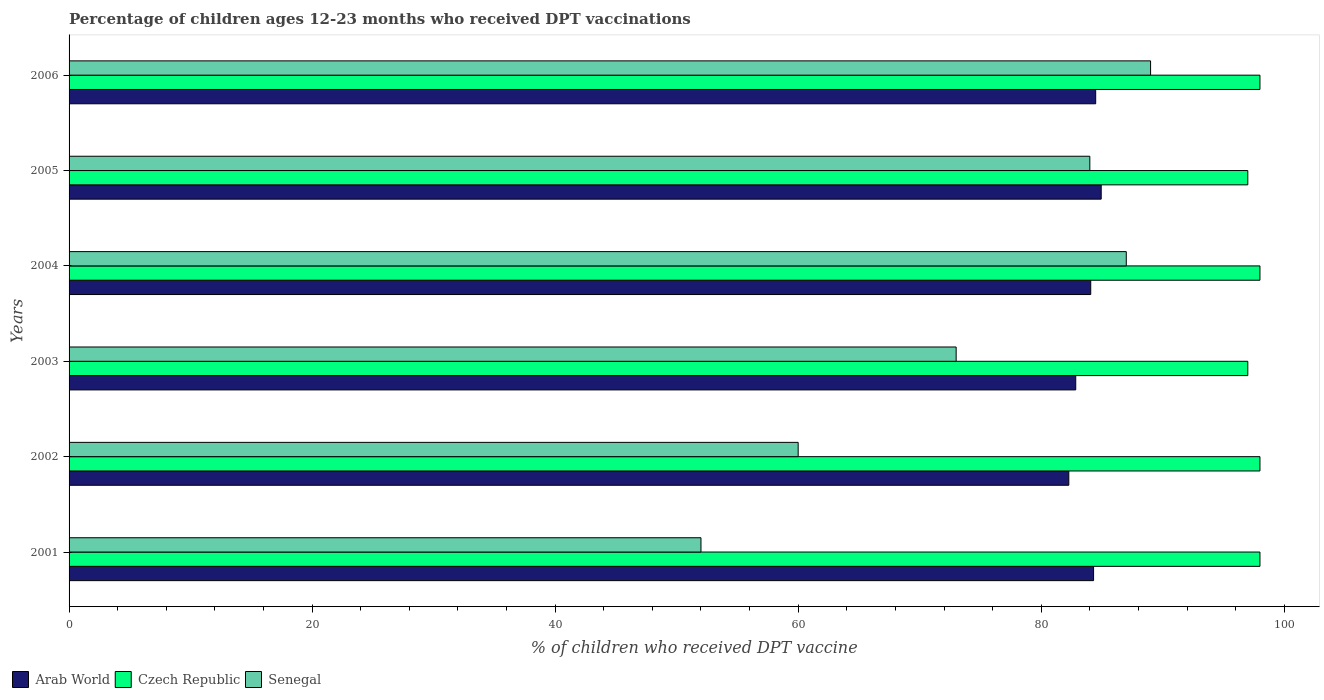Are the number of bars per tick equal to the number of legend labels?
Provide a succinct answer. Yes. Are the number of bars on each tick of the Y-axis equal?
Provide a succinct answer. Yes. How many bars are there on the 6th tick from the bottom?
Your response must be concise. 3. What is the label of the 5th group of bars from the top?
Your answer should be compact. 2002. Across all years, what is the maximum percentage of children who received DPT vaccination in Arab World?
Your answer should be compact. 84.94. Across all years, what is the minimum percentage of children who received DPT vaccination in Arab World?
Your response must be concise. 82.27. What is the total percentage of children who received DPT vaccination in Arab World in the graph?
Offer a very short reply. 502.92. What is the difference between the percentage of children who received DPT vaccination in Arab World in 2001 and that in 2003?
Your answer should be compact. 1.47. What is the difference between the percentage of children who received DPT vaccination in Czech Republic in 2006 and the percentage of children who received DPT vaccination in Senegal in 2003?
Offer a terse response. 25. What is the average percentage of children who received DPT vaccination in Senegal per year?
Offer a terse response. 74.17. In the year 2002, what is the difference between the percentage of children who received DPT vaccination in Czech Republic and percentage of children who received DPT vaccination in Arab World?
Your response must be concise. 15.73. What is the ratio of the percentage of children who received DPT vaccination in Senegal in 2001 to that in 2002?
Your response must be concise. 0.87. Is the percentage of children who received DPT vaccination in Senegal in 2005 less than that in 2006?
Offer a very short reply. Yes. What is the difference between the highest and the lowest percentage of children who received DPT vaccination in Arab World?
Your response must be concise. 2.67. Is the sum of the percentage of children who received DPT vaccination in Senegal in 2001 and 2005 greater than the maximum percentage of children who received DPT vaccination in Czech Republic across all years?
Give a very brief answer. Yes. What does the 2nd bar from the top in 2006 represents?
Make the answer very short. Czech Republic. What does the 1st bar from the bottom in 2005 represents?
Offer a terse response. Arab World. How many bars are there?
Offer a terse response. 18. What is the difference between two consecutive major ticks on the X-axis?
Give a very brief answer. 20. Does the graph contain grids?
Your answer should be compact. No. How many legend labels are there?
Offer a terse response. 3. What is the title of the graph?
Provide a succinct answer. Percentage of children ages 12-23 months who received DPT vaccinations. What is the label or title of the X-axis?
Make the answer very short. % of children who received DPT vaccine. What is the label or title of the Y-axis?
Your answer should be very brief. Years. What is the % of children who received DPT vaccine in Arab World in 2001?
Ensure brevity in your answer.  84.31. What is the % of children who received DPT vaccine of Arab World in 2002?
Your answer should be compact. 82.27. What is the % of children who received DPT vaccine of Arab World in 2003?
Provide a short and direct response. 82.84. What is the % of children who received DPT vaccine of Czech Republic in 2003?
Offer a very short reply. 97. What is the % of children who received DPT vaccine of Arab World in 2004?
Offer a terse response. 84.08. What is the % of children who received DPT vaccine of Arab World in 2005?
Ensure brevity in your answer.  84.94. What is the % of children who received DPT vaccine of Czech Republic in 2005?
Offer a very short reply. 97. What is the % of children who received DPT vaccine in Arab World in 2006?
Ensure brevity in your answer.  84.48. What is the % of children who received DPT vaccine in Senegal in 2006?
Provide a short and direct response. 89. Across all years, what is the maximum % of children who received DPT vaccine of Arab World?
Offer a terse response. 84.94. Across all years, what is the maximum % of children who received DPT vaccine in Czech Republic?
Offer a terse response. 98. Across all years, what is the maximum % of children who received DPT vaccine in Senegal?
Your response must be concise. 89. Across all years, what is the minimum % of children who received DPT vaccine in Arab World?
Give a very brief answer. 82.27. Across all years, what is the minimum % of children who received DPT vaccine of Czech Republic?
Provide a succinct answer. 97. What is the total % of children who received DPT vaccine in Arab World in the graph?
Your answer should be very brief. 502.92. What is the total % of children who received DPT vaccine in Czech Republic in the graph?
Your response must be concise. 586. What is the total % of children who received DPT vaccine of Senegal in the graph?
Provide a short and direct response. 445. What is the difference between the % of children who received DPT vaccine of Arab World in 2001 and that in 2002?
Provide a short and direct response. 2.04. What is the difference between the % of children who received DPT vaccine of Senegal in 2001 and that in 2002?
Make the answer very short. -8. What is the difference between the % of children who received DPT vaccine of Arab World in 2001 and that in 2003?
Provide a succinct answer. 1.47. What is the difference between the % of children who received DPT vaccine in Czech Republic in 2001 and that in 2003?
Make the answer very short. 1. What is the difference between the % of children who received DPT vaccine in Arab World in 2001 and that in 2004?
Give a very brief answer. 0.23. What is the difference between the % of children who received DPT vaccine of Czech Republic in 2001 and that in 2004?
Your answer should be very brief. 0. What is the difference between the % of children who received DPT vaccine in Senegal in 2001 and that in 2004?
Give a very brief answer. -35. What is the difference between the % of children who received DPT vaccine in Arab World in 2001 and that in 2005?
Keep it short and to the point. -0.63. What is the difference between the % of children who received DPT vaccine of Senegal in 2001 and that in 2005?
Make the answer very short. -32. What is the difference between the % of children who received DPT vaccine in Arab World in 2001 and that in 2006?
Offer a very short reply. -0.17. What is the difference between the % of children who received DPT vaccine of Senegal in 2001 and that in 2006?
Keep it short and to the point. -37. What is the difference between the % of children who received DPT vaccine in Arab World in 2002 and that in 2003?
Provide a short and direct response. -0.57. What is the difference between the % of children who received DPT vaccine of Czech Republic in 2002 and that in 2003?
Make the answer very short. 1. What is the difference between the % of children who received DPT vaccine of Arab World in 2002 and that in 2004?
Offer a terse response. -1.8. What is the difference between the % of children who received DPT vaccine of Senegal in 2002 and that in 2004?
Offer a very short reply. -27. What is the difference between the % of children who received DPT vaccine in Arab World in 2002 and that in 2005?
Provide a succinct answer. -2.67. What is the difference between the % of children who received DPT vaccine in Czech Republic in 2002 and that in 2005?
Your answer should be very brief. 1. What is the difference between the % of children who received DPT vaccine of Senegal in 2002 and that in 2005?
Offer a very short reply. -24. What is the difference between the % of children who received DPT vaccine in Arab World in 2002 and that in 2006?
Provide a succinct answer. -2.21. What is the difference between the % of children who received DPT vaccine of Czech Republic in 2002 and that in 2006?
Your answer should be very brief. 0. What is the difference between the % of children who received DPT vaccine of Arab World in 2003 and that in 2004?
Offer a terse response. -1.23. What is the difference between the % of children who received DPT vaccine in Czech Republic in 2003 and that in 2004?
Offer a terse response. -1. What is the difference between the % of children who received DPT vaccine of Arab World in 2003 and that in 2005?
Offer a very short reply. -2.1. What is the difference between the % of children who received DPT vaccine in Czech Republic in 2003 and that in 2005?
Make the answer very short. 0. What is the difference between the % of children who received DPT vaccine in Arab World in 2003 and that in 2006?
Provide a short and direct response. -1.64. What is the difference between the % of children who received DPT vaccine of Czech Republic in 2003 and that in 2006?
Make the answer very short. -1. What is the difference between the % of children who received DPT vaccine of Arab World in 2004 and that in 2005?
Your answer should be very brief. -0.86. What is the difference between the % of children who received DPT vaccine in Czech Republic in 2004 and that in 2005?
Provide a succinct answer. 1. What is the difference between the % of children who received DPT vaccine in Arab World in 2004 and that in 2006?
Give a very brief answer. -0.41. What is the difference between the % of children who received DPT vaccine of Czech Republic in 2004 and that in 2006?
Provide a short and direct response. 0. What is the difference between the % of children who received DPT vaccine in Senegal in 2004 and that in 2006?
Make the answer very short. -2. What is the difference between the % of children who received DPT vaccine in Arab World in 2005 and that in 2006?
Ensure brevity in your answer.  0.45. What is the difference between the % of children who received DPT vaccine in Arab World in 2001 and the % of children who received DPT vaccine in Czech Republic in 2002?
Make the answer very short. -13.69. What is the difference between the % of children who received DPT vaccine of Arab World in 2001 and the % of children who received DPT vaccine of Senegal in 2002?
Offer a very short reply. 24.31. What is the difference between the % of children who received DPT vaccine in Czech Republic in 2001 and the % of children who received DPT vaccine in Senegal in 2002?
Your answer should be compact. 38. What is the difference between the % of children who received DPT vaccine in Arab World in 2001 and the % of children who received DPT vaccine in Czech Republic in 2003?
Keep it short and to the point. -12.69. What is the difference between the % of children who received DPT vaccine of Arab World in 2001 and the % of children who received DPT vaccine of Senegal in 2003?
Provide a succinct answer. 11.31. What is the difference between the % of children who received DPT vaccine of Arab World in 2001 and the % of children who received DPT vaccine of Czech Republic in 2004?
Your answer should be compact. -13.69. What is the difference between the % of children who received DPT vaccine in Arab World in 2001 and the % of children who received DPT vaccine in Senegal in 2004?
Keep it short and to the point. -2.69. What is the difference between the % of children who received DPT vaccine of Czech Republic in 2001 and the % of children who received DPT vaccine of Senegal in 2004?
Your response must be concise. 11. What is the difference between the % of children who received DPT vaccine in Arab World in 2001 and the % of children who received DPT vaccine in Czech Republic in 2005?
Your answer should be very brief. -12.69. What is the difference between the % of children who received DPT vaccine in Arab World in 2001 and the % of children who received DPT vaccine in Senegal in 2005?
Provide a short and direct response. 0.31. What is the difference between the % of children who received DPT vaccine in Czech Republic in 2001 and the % of children who received DPT vaccine in Senegal in 2005?
Ensure brevity in your answer.  14. What is the difference between the % of children who received DPT vaccine of Arab World in 2001 and the % of children who received DPT vaccine of Czech Republic in 2006?
Make the answer very short. -13.69. What is the difference between the % of children who received DPT vaccine of Arab World in 2001 and the % of children who received DPT vaccine of Senegal in 2006?
Your response must be concise. -4.69. What is the difference between the % of children who received DPT vaccine in Arab World in 2002 and the % of children who received DPT vaccine in Czech Republic in 2003?
Make the answer very short. -14.73. What is the difference between the % of children who received DPT vaccine in Arab World in 2002 and the % of children who received DPT vaccine in Senegal in 2003?
Give a very brief answer. 9.27. What is the difference between the % of children who received DPT vaccine of Czech Republic in 2002 and the % of children who received DPT vaccine of Senegal in 2003?
Provide a short and direct response. 25. What is the difference between the % of children who received DPT vaccine of Arab World in 2002 and the % of children who received DPT vaccine of Czech Republic in 2004?
Offer a terse response. -15.73. What is the difference between the % of children who received DPT vaccine of Arab World in 2002 and the % of children who received DPT vaccine of Senegal in 2004?
Your response must be concise. -4.73. What is the difference between the % of children who received DPT vaccine of Czech Republic in 2002 and the % of children who received DPT vaccine of Senegal in 2004?
Your answer should be compact. 11. What is the difference between the % of children who received DPT vaccine in Arab World in 2002 and the % of children who received DPT vaccine in Czech Republic in 2005?
Offer a terse response. -14.73. What is the difference between the % of children who received DPT vaccine of Arab World in 2002 and the % of children who received DPT vaccine of Senegal in 2005?
Offer a terse response. -1.73. What is the difference between the % of children who received DPT vaccine in Czech Republic in 2002 and the % of children who received DPT vaccine in Senegal in 2005?
Your response must be concise. 14. What is the difference between the % of children who received DPT vaccine of Arab World in 2002 and the % of children who received DPT vaccine of Czech Republic in 2006?
Provide a short and direct response. -15.73. What is the difference between the % of children who received DPT vaccine of Arab World in 2002 and the % of children who received DPT vaccine of Senegal in 2006?
Offer a very short reply. -6.73. What is the difference between the % of children who received DPT vaccine of Czech Republic in 2002 and the % of children who received DPT vaccine of Senegal in 2006?
Your answer should be very brief. 9. What is the difference between the % of children who received DPT vaccine in Arab World in 2003 and the % of children who received DPT vaccine in Czech Republic in 2004?
Offer a terse response. -15.16. What is the difference between the % of children who received DPT vaccine in Arab World in 2003 and the % of children who received DPT vaccine in Senegal in 2004?
Your response must be concise. -4.16. What is the difference between the % of children who received DPT vaccine in Arab World in 2003 and the % of children who received DPT vaccine in Czech Republic in 2005?
Your answer should be compact. -14.16. What is the difference between the % of children who received DPT vaccine of Arab World in 2003 and the % of children who received DPT vaccine of Senegal in 2005?
Ensure brevity in your answer.  -1.16. What is the difference between the % of children who received DPT vaccine in Arab World in 2003 and the % of children who received DPT vaccine in Czech Republic in 2006?
Offer a very short reply. -15.16. What is the difference between the % of children who received DPT vaccine of Arab World in 2003 and the % of children who received DPT vaccine of Senegal in 2006?
Make the answer very short. -6.16. What is the difference between the % of children who received DPT vaccine of Czech Republic in 2003 and the % of children who received DPT vaccine of Senegal in 2006?
Keep it short and to the point. 8. What is the difference between the % of children who received DPT vaccine of Arab World in 2004 and the % of children who received DPT vaccine of Czech Republic in 2005?
Your answer should be compact. -12.92. What is the difference between the % of children who received DPT vaccine in Arab World in 2004 and the % of children who received DPT vaccine in Senegal in 2005?
Your answer should be compact. 0.08. What is the difference between the % of children who received DPT vaccine of Arab World in 2004 and the % of children who received DPT vaccine of Czech Republic in 2006?
Offer a very short reply. -13.92. What is the difference between the % of children who received DPT vaccine in Arab World in 2004 and the % of children who received DPT vaccine in Senegal in 2006?
Keep it short and to the point. -4.92. What is the difference between the % of children who received DPT vaccine in Arab World in 2005 and the % of children who received DPT vaccine in Czech Republic in 2006?
Your answer should be compact. -13.06. What is the difference between the % of children who received DPT vaccine in Arab World in 2005 and the % of children who received DPT vaccine in Senegal in 2006?
Provide a succinct answer. -4.06. What is the difference between the % of children who received DPT vaccine of Czech Republic in 2005 and the % of children who received DPT vaccine of Senegal in 2006?
Keep it short and to the point. 8. What is the average % of children who received DPT vaccine in Arab World per year?
Make the answer very short. 83.82. What is the average % of children who received DPT vaccine in Czech Republic per year?
Your answer should be compact. 97.67. What is the average % of children who received DPT vaccine of Senegal per year?
Ensure brevity in your answer.  74.17. In the year 2001, what is the difference between the % of children who received DPT vaccine in Arab World and % of children who received DPT vaccine in Czech Republic?
Your answer should be compact. -13.69. In the year 2001, what is the difference between the % of children who received DPT vaccine of Arab World and % of children who received DPT vaccine of Senegal?
Give a very brief answer. 32.31. In the year 2001, what is the difference between the % of children who received DPT vaccine in Czech Republic and % of children who received DPT vaccine in Senegal?
Keep it short and to the point. 46. In the year 2002, what is the difference between the % of children who received DPT vaccine of Arab World and % of children who received DPT vaccine of Czech Republic?
Offer a terse response. -15.73. In the year 2002, what is the difference between the % of children who received DPT vaccine in Arab World and % of children who received DPT vaccine in Senegal?
Offer a very short reply. 22.27. In the year 2002, what is the difference between the % of children who received DPT vaccine in Czech Republic and % of children who received DPT vaccine in Senegal?
Make the answer very short. 38. In the year 2003, what is the difference between the % of children who received DPT vaccine in Arab World and % of children who received DPT vaccine in Czech Republic?
Provide a succinct answer. -14.16. In the year 2003, what is the difference between the % of children who received DPT vaccine of Arab World and % of children who received DPT vaccine of Senegal?
Your answer should be compact. 9.84. In the year 2003, what is the difference between the % of children who received DPT vaccine of Czech Republic and % of children who received DPT vaccine of Senegal?
Provide a succinct answer. 24. In the year 2004, what is the difference between the % of children who received DPT vaccine of Arab World and % of children who received DPT vaccine of Czech Republic?
Make the answer very short. -13.92. In the year 2004, what is the difference between the % of children who received DPT vaccine of Arab World and % of children who received DPT vaccine of Senegal?
Ensure brevity in your answer.  -2.92. In the year 2004, what is the difference between the % of children who received DPT vaccine in Czech Republic and % of children who received DPT vaccine in Senegal?
Offer a very short reply. 11. In the year 2005, what is the difference between the % of children who received DPT vaccine of Arab World and % of children who received DPT vaccine of Czech Republic?
Keep it short and to the point. -12.06. In the year 2005, what is the difference between the % of children who received DPT vaccine in Arab World and % of children who received DPT vaccine in Senegal?
Your answer should be very brief. 0.94. In the year 2006, what is the difference between the % of children who received DPT vaccine in Arab World and % of children who received DPT vaccine in Czech Republic?
Offer a very short reply. -13.52. In the year 2006, what is the difference between the % of children who received DPT vaccine of Arab World and % of children who received DPT vaccine of Senegal?
Offer a terse response. -4.52. In the year 2006, what is the difference between the % of children who received DPT vaccine of Czech Republic and % of children who received DPT vaccine of Senegal?
Provide a short and direct response. 9. What is the ratio of the % of children who received DPT vaccine in Arab World in 2001 to that in 2002?
Your answer should be very brief. 1.02. What is the ratio of the % of children who received DPT vaccine of Czech Republic in 2001 to that in 2002?
Offer a very short reply. 1. What is the ratio of the % of children who received DPT vaccine in Senegal in 2001 to that in 2002?
Make the answer very short. 0.87. What is the ratio of the % of children who received DPT vaccine of Arab World in 2001 to that in 2003?
Your answer should be compact. 1.02. What is the ratio of the % of children who received DPT vaccine of Czech Republic in 2001 to that in 2003?
Give a very brief answer. 1.01. What is the ratio of the % of children who received DPT vaccine in Senegal in 2001 to that in 2003?
Keep it short and to the point. 0.71. What is the ratio of the % of children who received DPT vaccine of Senegal in 2001 to that in 2004?
Give a very brief answer. 0.6. What is the ratio of the % of children who received DPT vaccine in Czech Republic in 2001 to that in 2005?
Make the answer very short. 1.01. What is the ratio of the % of children who received DPT vaccine of Senegal in 2001 to that in 2005?
Provide a succinct answer. 0.62. What is the ratio of the % of children who received DPT vaccine of Arab World in 2001 to that in 2006?
Keep it short and to the point. 1. What is the ratio of the % of children who received DPT vaccine of Czech Republic in 2001 to that in 2006?
Make the answer very short. 1. What is the ratio of the % of children who received DPT vaccine in Senegal in 2001 to that in 2006?
Provide a succinct answer. 0.58. What is the ratio of the % of children who received DPT vaccine in Arab World in 2002 to that in 2003?
Provide a succinct answer. 0.99. What is the ratio of the % of children who received DPT vaccine in Czech Republic in 2002 to that in 2003?
Ensure brevity in your answer.  1.01. What is the ratio of the % of children who received DPT vaccine in Senegal in 2002 to that in 2003?
Keep it short and to the point. 0.82. What is the ratio of the % of children who received DPT vaccine in Arab World in 2002 to that in 2004?
Your answer should be very brief. 0.98. What is the ratio of the % of children who received DPT vaccine in Czech Republic in 2002 to that in 2004?
Make the answer very short. 1. What is the ratio of the % of children who received DPT vaccine in Senegal in 2002 to that in 2004?
Keep it short and to the point. 0.69. What is the ratio of the % of children who received DPT vaccine in Arab World in 2002 to that in 2005?
Your response must be concise. 0.97. What is the ratio of the % of children who received DPT vaccine of Czech Republic in 2002 to that in 2005?
Ensure brevity in your answer.  1.01. What is the ratio of the % of children who received DPT vaccine in Senegal in 2002 to that in 2005?
Your response must be concise. 0.71. What is the ratio of the % of children who received DPT vaccine in Arab World in 2002 to that in 2006?
Your answer should be compact. 0.97. What is the ratio of the % of children who received DPT vaccine in Senegal in 2002 to that in 2006?
Give a very brief answer. 0.67. What is the ratio of the % of children who received DPT vaccine of Arab World in 2003 to that in 2004?
Offer a very short reply. 0.99. What is the ratio of the % of children who received DPT vaccine in Senegal in 2003 to that in 2004?
Your response must be concise. 0.84. What is the ratio of the % of children who received DPT vaccine in Arab World in 2003 to that in 2005?
Your answer should be compact. 0.98. What is the ratio of the % of children who received DPT vaccine of Czech Republic in 2003 to that in 2005?
Ensure brevity in your answer.  1. What is the ratio of the % of children who received DPT vaccine of Senegal in 2003 to that in 2005?
Your response must be concise. 0.87. What is the ratio of the % of children who received DPT vaccine of Arab World in 2003 to that in 2006?
Give a very brief answer. 0.98. What is the ratio of the % of children who received DPT vaccine of Czech Republic in 2003 to that in 2006?
Make the answer very short. 0.99. What is the ratio of the % of children who received DPT vaccine of Senegal in 2003 to that in 2006?
Keep it short and to the point. 0.82. What is the ratio of the % of children who received DPT vaccine in Czech Republic in 2004 to that in 2005?
Make the answer very short. 1.01. What is the ratio of the % of children who received DPT vaccine in Senegal in 2004 to that in 2005?
Keep it short and to the point. 1.04. What is the ratio of the % of children who received DPT vaccine of Arab World in 2004 to that in 2006?
Give a very brief answer. 1. What is the ratio of the % of children who received DPT vaccine in Czech Republic in 2004 to that in 2006?
Your response must be concise. 1. What is the ratio of the % of children who received DPT vaccine of Senegal in 2004 to that in 2006?
Ensure brevity in your answer.  0.98. What is the ratio of the % of children who received DPT vaccine in Arab World in 2005 to that in 2006?
Keep it short and to the point. 1.01. What is the ratio of the % of children who received DPT vaccine of Czech Republic in 2005 to that in 2006?
Make the answer very short. 0.99. What is the ratio of the % of children who received DPT vaccine of Senegal in 2005 to that in 2006?
Your answer should be compact. 0.94. What is the difference between the highest and the second highest % of children who received DPT vaccine of Arab World?
Provide a short and direct response. 0.45. What is the difference between the highest and the second highest % of children who received DPT vaccine in Czech Republic?
Your response must be concise. 0. What is the difference between the highest and the second highest % of children who received DPT vaccine of Senegal?
Your response must be concise. 2. What is the difference between the highest and the lowest % of children who received DPT vaccine in Arab World?
Your answer should be very brief. 2.67. What is the difference between the highest and the lowest % of children who received DPT vaccine in Czech Republic?
Your answer should be very brief. 1. 